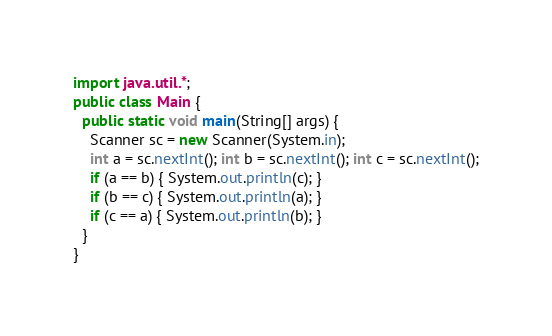<code> <loc_0><loc_0><loc_500><loc_500><_Java_>import java.util.*;
public class Main {
  public static void main(String[] args) {
    Scanner sc = new Scanner(System.in);
	int a = sc.nextInt(); int b = sc.nextInt(); int c = sc.nextInt();
	if (a == b) { System.out.println(c); }
  	if (b == c) { System.out.println(a); }
	if (c == a) { System.out.println(b); }
  }
}</code> 